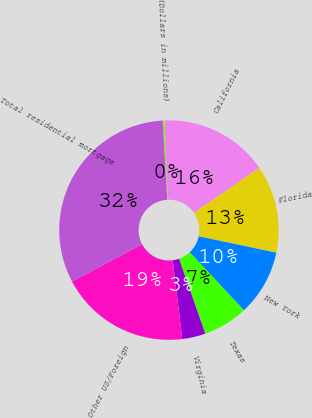<chart> <loc_0><loc_0><loc_500><loc_500><pie_chart><fcel>(Dollars in millions)<fcel>California<fcel>Florida<fcel>New York<fcel>Texas<fcel>Virginia<fcel>Other US/Foreign<fcel>Total residential mortgage<nl><fcel>0.28%<fcel>16.05%<fcel>12.89%<fcel>9.74%<fcel>6.59%<fcel>3.43%<fcel>19.2%<fcel>31.82%<nl></chart> 